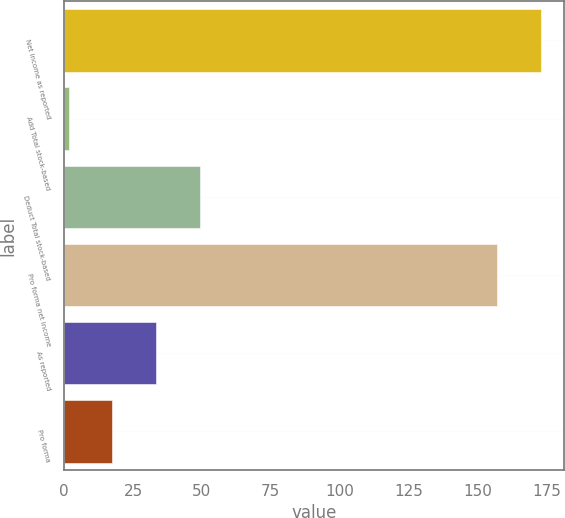Convert chart. <chart><loc_0><loc_0><loc_500><loc_500><bar_chart><fcel>Net income as reported<fcel>Add Total stock-based<fcel>Deduct Total stock-based<fcel>Pro forma net income<fcel>As reported<fcel>Pro forma<nl><fcel>172.86<fcel>1.6<fcel>49.18<fcel>157<fcel>33.32<fcel>17.46<nl></chart> 